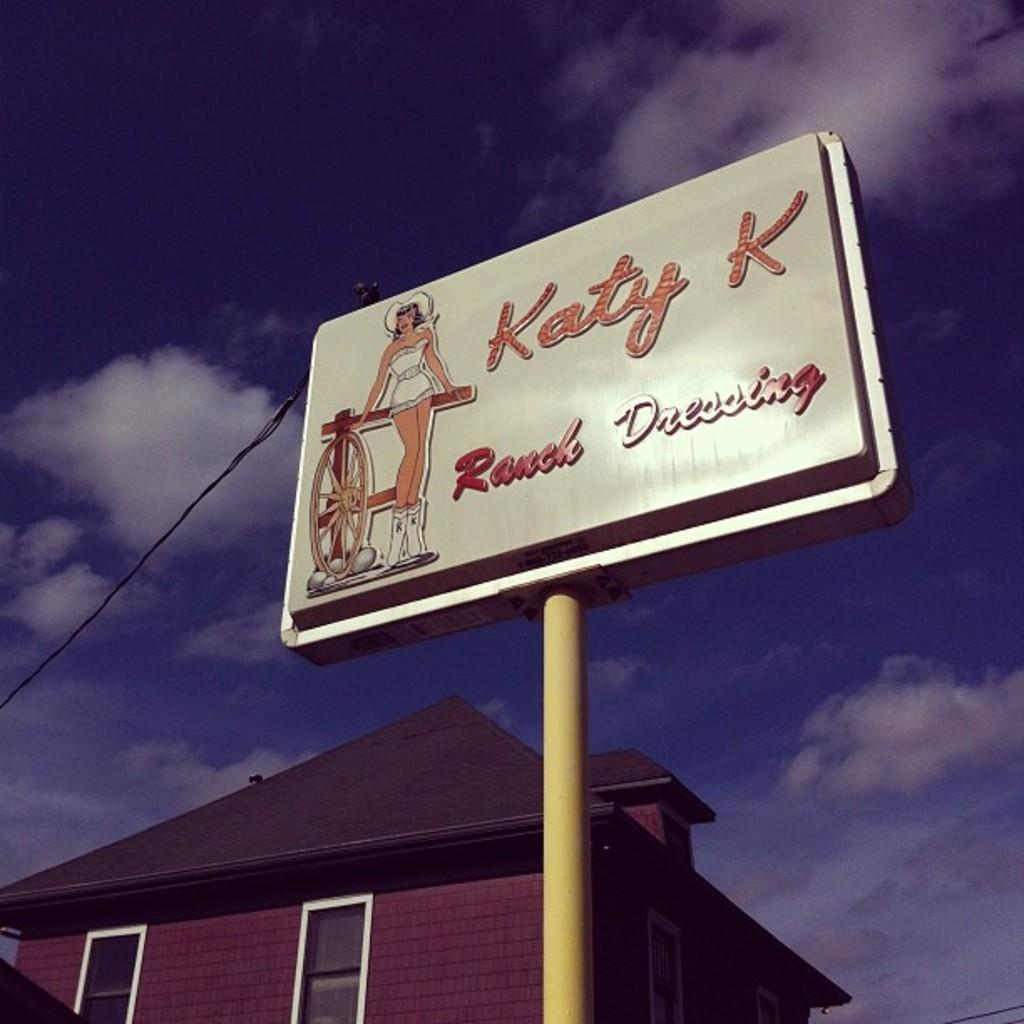<image>
Describe the image concisely. A sign post next to a house shows a woman and advertises Katy K Ranch dressing. 